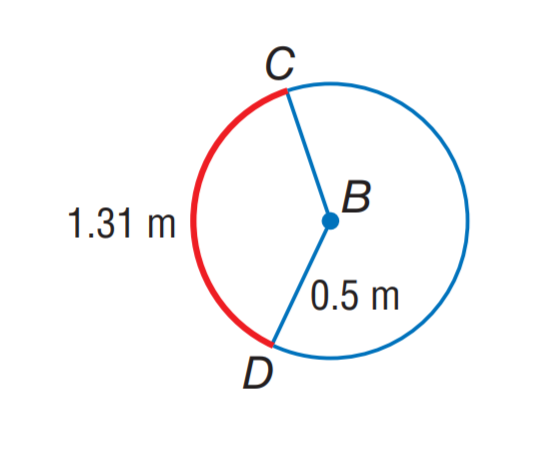Answer the mathemtical geometry problem and directly provide the correct option letter.
Question: Find m \widehat C D.
Choices: A: 120 B: 135 C: 150 D: 180 C 